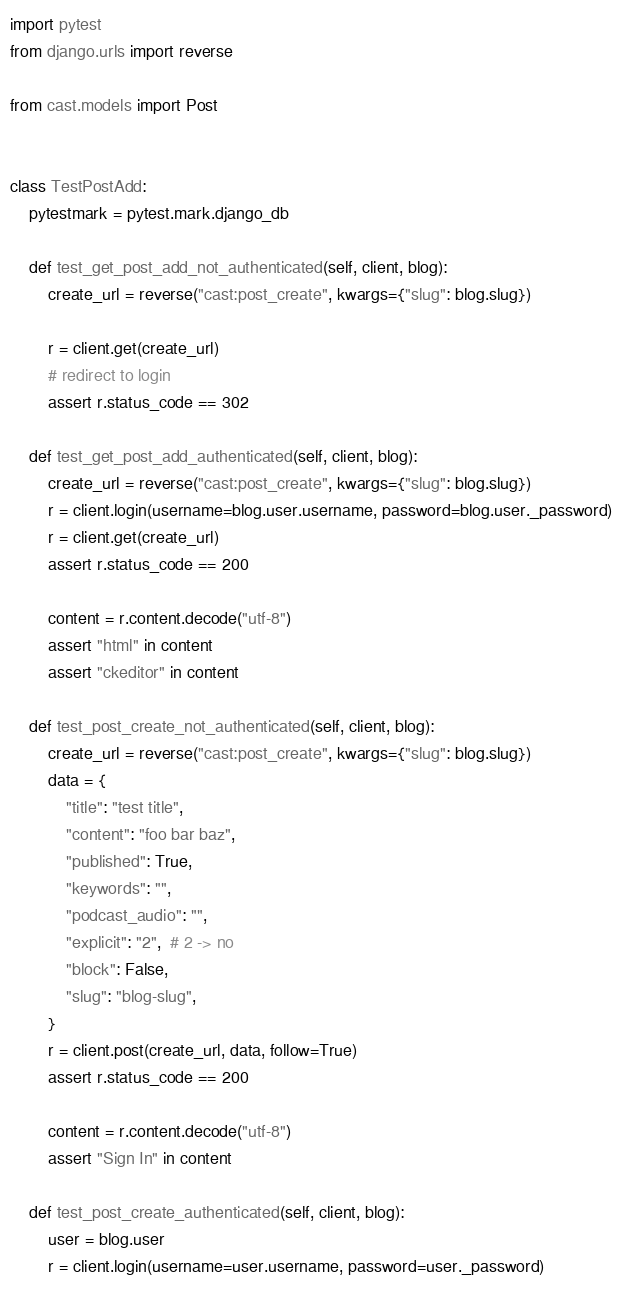<code> <loc_0><loc_0><loc_500><loc_500><_Python_>import pytest
from django.urls import reverse

from cast.models import Post


class TestPostAdd:
    pytestmark = pytest.mark.django_db

    def test_get_post_add_not_authenticated(self, client, blog):
        create_url = reverse("cast:post_create", kwargs={"slug": blog.slug})

        r = client.get(create_url)
        # redirect to login
        assert r.status_code == 302

    def test_get_post_add_authenticated(self, client, blog):
        create_url = reverse("cast:post_create", kwargs={"slug": blog.slug})
        r = client.login(username=blog.user.username, password=blog.user._password)
        r = client.get(create_url)
        assert r.status_code == 200

        content = r.content.decode("utf-8")
        assert "html" in content
        assert "ckeditor" in content

    def test_post_create_not_authenticated(self, client, blog):
        create_url = reverse("cast:post_create", kwargs={"slug": blog.slug})
        data = {
            "title": "test title",
            "content": "foo bar baz",
            "published": True,
            "keywords": "",
            "podcast_audio": "",
            "explicit": "2",  # 2 -> no
            "block": False,
            "slug": "blog-slug",
        }
        r = client.post(create_url, data, follow=True)
        assert r.status_code == 200

        content = r.content.decode("utf-8")
        assert "Sign In" in content

    def test_post_create_authenticated(self, client, blog):
        user = blog.user
        r = client.login(username=user.username, password=user._password)
</code> 